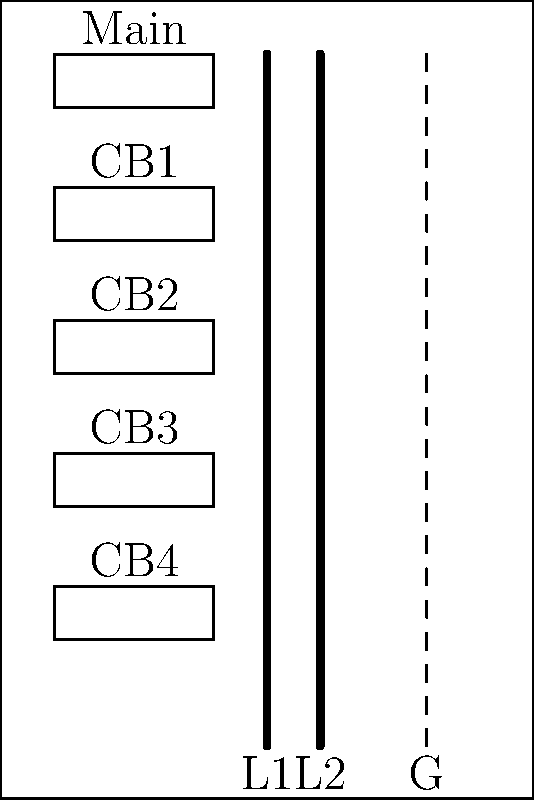As a regulatory compliance officer reviewing an electrical panel layout, which of the following issues violates the National Electrical Code (NEC) requirements for residential panel installations?

a) The ground bar is isolated from the neutral bar
b) There are no arc fault circuit interrupters (AFCIs) visible
c) The main breaker is not at the top of the panel
d) The panel has fewer than 42 circuits To answer this question, we need to consider the NEC requirements for residential electrical panels:

1. Ground and neutral bars: In a main service panel, the ground and neutral bars should be bonded together. The diagram shows a separate ground bar (dashed line), which is correct for a sub-panel but not for a main panel.

2. AFCIs: While AFCIs are required for many residential circuits, they are not always visually distinguishable from regular circuit breakers in a diagram. Their absence in the image doesn't necessarily indicate a violation.

3. Main breaker position: The NEC does not specify that the main breaker must be at the top of the panel. It can be in various positions, including the top, bottom, or center.

4. Number of circuits: The NEC does not mandate a minimum number of circuits for residential panels. The panel size depends on the specific needs of the installation.

5. Bus bar arrangement: The diagram shows two bus bars (L1 and L2), which is correct for a 120/240V single-phase system commonly used in residential applications.

Considering these points, none of the given options definitively violates NEC requirements based solely on the information provided in the diagram. However, the most potentially problematic issue would be the separate ground bar, as it could be incorrect if this is a main service panel.
Answer: None of the options definitively violates NEC requirements based solely on the given diagram. 